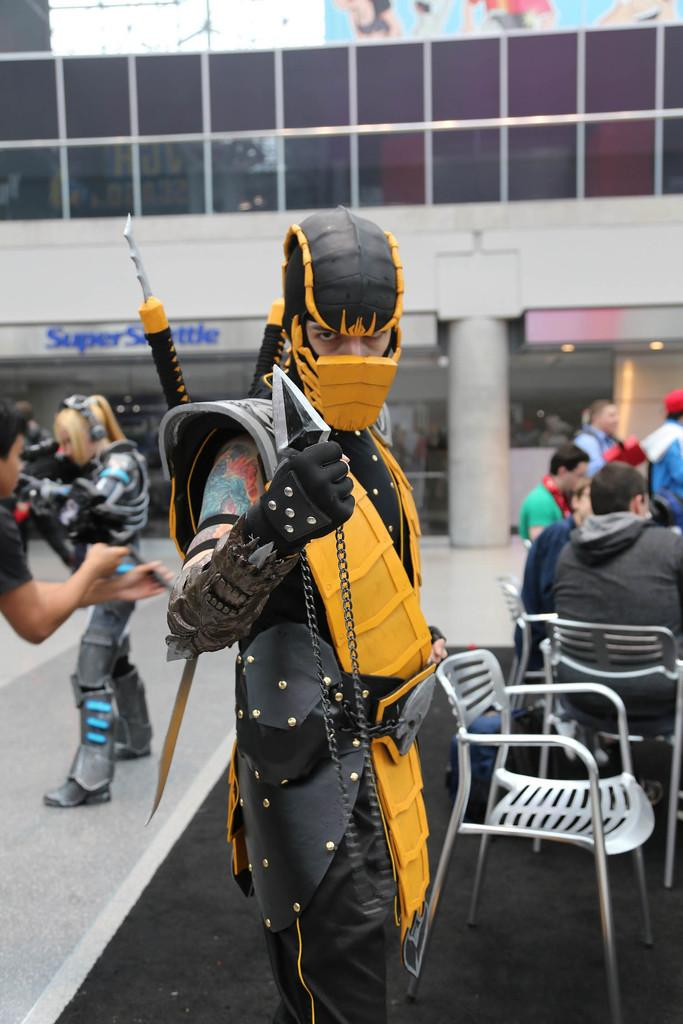Who is present in the image? There is a man in the image. What is the man wearing? The man is wearing a costume. Are there any other people in the image? Yes, there are other people in the image. What are the other people doing? The other people are sitting on chairs. What type of butter can be seen on the window in the image? There is no butter or window present in the image. What kind of tank is visible in the background of the image? There is no tank visible in the image. 